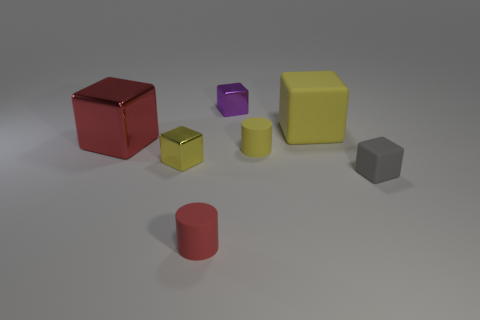What is the shape of the red object that is the same size as the purple metal object?
Make the answer very short. Cylinder. There is a tiny metal cube that is in front of the big metal cube; what color is it?
Ensure brevity in your answer.  Yellow. There is a yellow rubber object that is on the left side of the big yellow matte block; are there any rubber blocks that are on the right side of it?
Provide a succinct answer. Yes. What number of objects are either metal things that are behind the large red shiny cube or small red things?
Give a very brief answer. 2. There is a yellow cube behind the small yellow object on the left side of the tiny red thing; what is its material?
Offer a terse response. Rubber. Are there the same number of small matte objects that are on the left side of the large red object and tiny purple things that are left of the tiny purple thing?
Keep it short and to the point. Yes. What number of things are yellow objects that are left of the large yellow matte thing or matte cylinders behind the small matte block?
Offer a very short reply. 2. There is a tiny block that is both on the left side of the yellow cylinder and in front of the small purple thing; what material is it?
Offer a very short reply. Metal. What is the size of the red thing left of the rubber cylinder that is in front of the tiny block that is to the right of the big yellow object?
Make the answer very short. Large. Are there more large objects than small gray things?
Provide a succinct answer. Yes. 